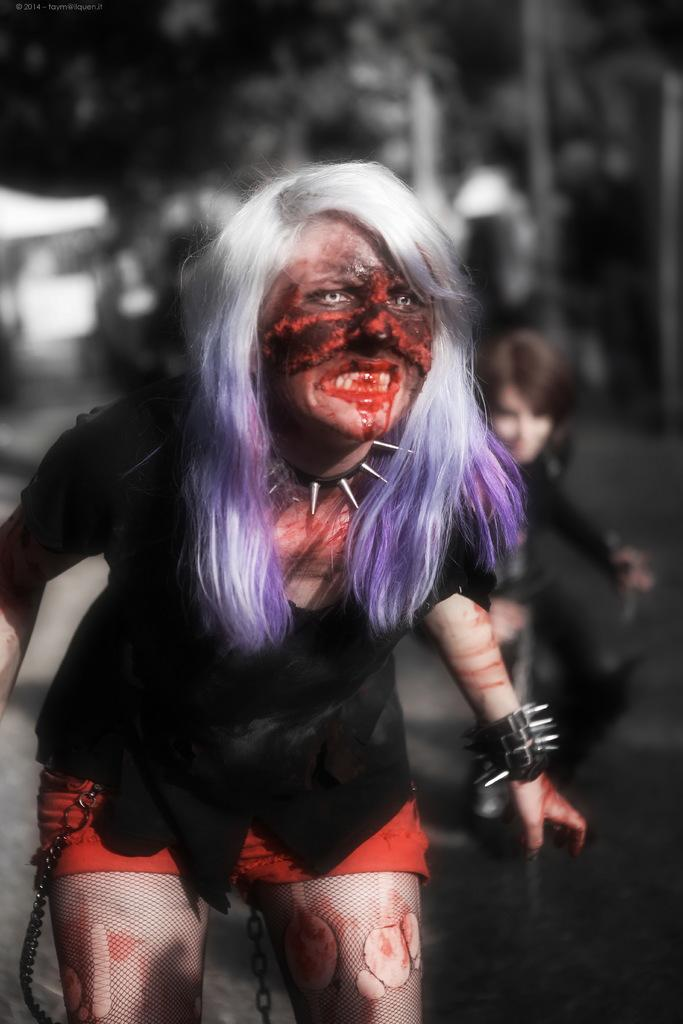Who is in the image? There is a woman in the image. What is the woman wearing? The woman is wearing a black dress. What might be suggested by the appearance of the image? The image appears to be from a Halloween party. Has the image been altered in any way? Yes, the image has been edited. What type of moon can be seen in the image? There is no moon visible in the image. What is the color of the wall behind the woman in the image? The provided facts do not mention the color of the wall behind the woman, so we cannot determine its color from the image. 